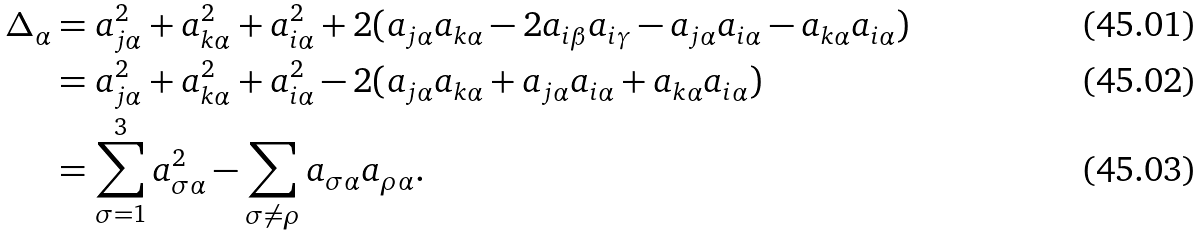<formula> <loc_0><loc_0><loc_500><loc_500>\Delta _ { \alpha } & = a _ { j \alpha } ^ { 2 } + a _ { k \alpha } ^ { 2 } + a _ { i \alpha } ^ { 2 } + 2 ( a _ { j \alpha } a _ { k \alpha } - 2 a _ { i \beta } a _ { i \gamma } - a _ { j \alpha } a _ { i \alpha } - a _ { k \alpha } a _ { i \alpha } ) \\ & = a _ { j \alpha } ^ { 2 } + a _ { k \alpha } ^ { 2 } + a _ { i \alpha } ^ { 2 } - 2 ( a _ { j \alpha } a _ { k \alpha } + a _ { j \alpha } a _ { i \alpha } + a _ { k \alpha } a _ { i \alpha } ) \\ & = \sum _ { \sigma = 1 } ^ { 3 } a _ { \sigma \alpha } ^ { 2 } - \sum _ { \sigma \neq \rho } a _ { \sigma \alpha } a _ { \rho \alpha } .</formula> 